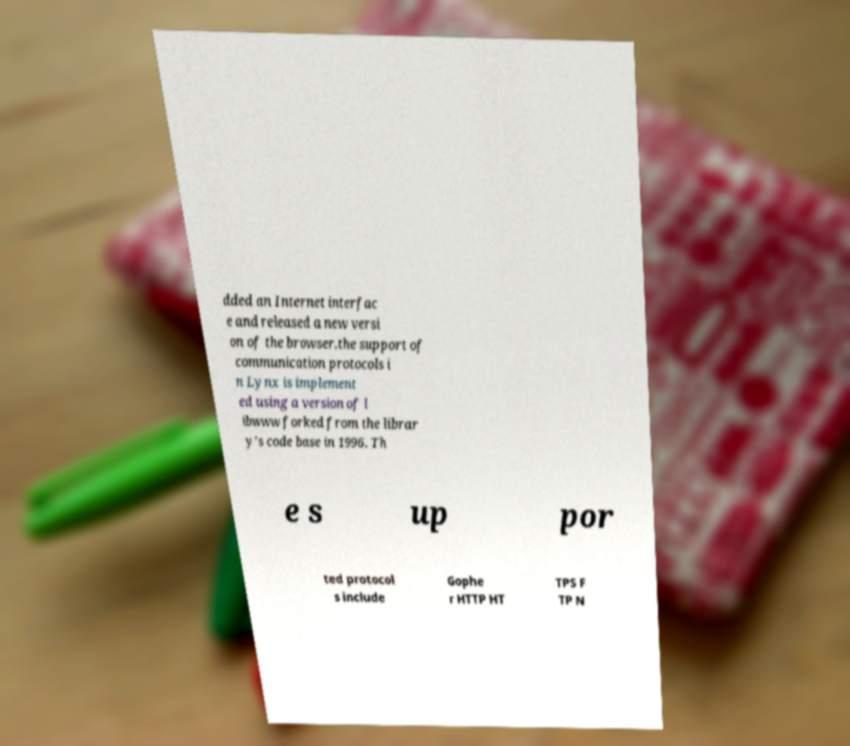I need the written content from this picture converted into text. Can you do that? dded an Internet interfac e and released a new versi on of the browser.the support of communication protocols i n Lynx is implement ed using a version of l ibwww forked from the librar y's code base in 1996. Th e s up por ted protocol s include Gophe r HTTP HT TPS F TP N 